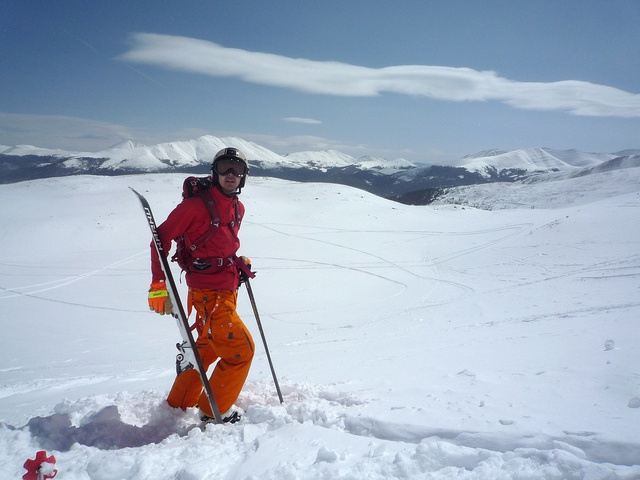Describe the objects in this image and their specific colors. I can see people in blue, maroon, black, and gray tones, skis in blue, black, darkgray, gray, and maroon tones, and backpack in blue, maroon, black, lightgray, and gray tones in this image. 